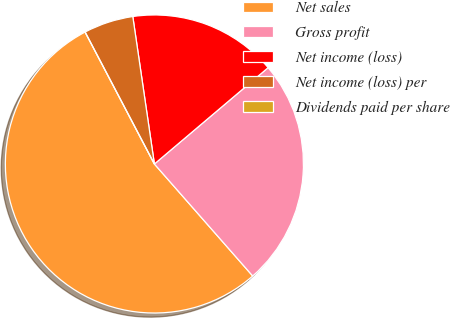<chart> <loc_0><loc_0><loc_500><loc_500><pie_chart><fcel>Net sales<fcel>Gross profit<fcel>Net income (loss)<fcel>Net income (loss) per<fcel>Dividends paid per share<nl><fcel>53.77%<fcel>24.72%<fcel>16.13%<fcel>5.38%<fcel>0.0%<nl></chart> 